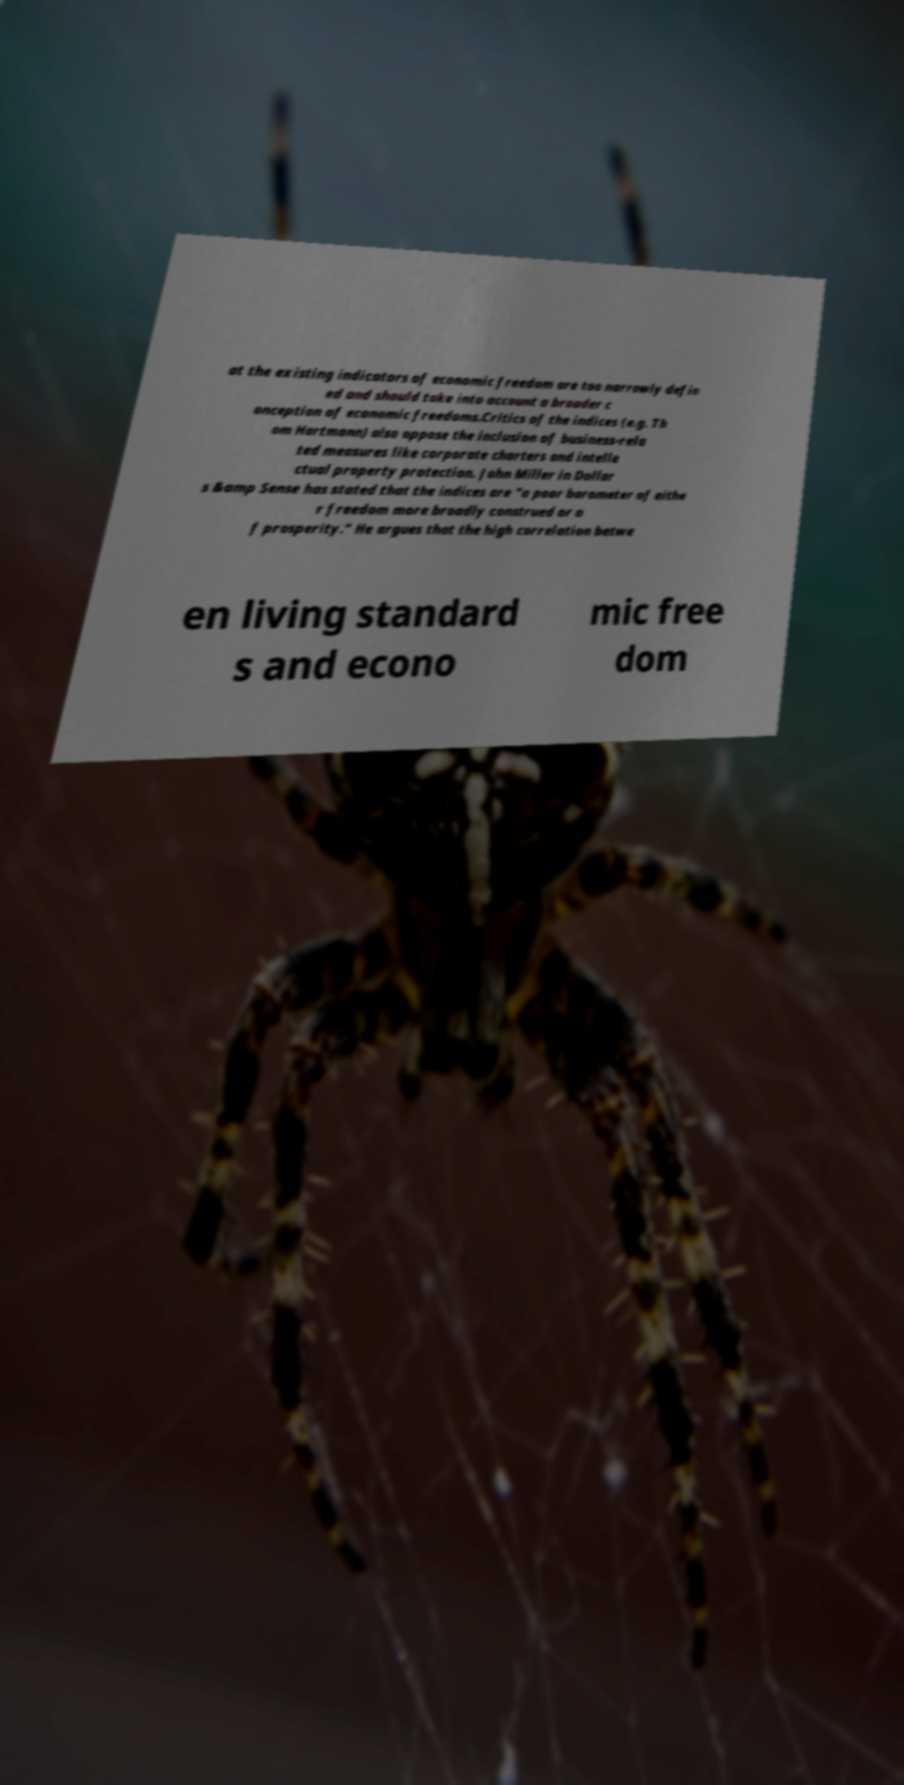Can you read and provide the text displayed in the image?This photo seems to have some interesting text. Can you extract and type it out for me? at the existing indicators of economic freedom are too narrowly defin ed and should take into account a broader c onception of economic freedoms.Critics of the indices (e.g. Th om Hartmann) also oppose the inclusion of business-rela ted measures like corporate charters and intelle ctual property protection. John Miller in Dollar s &amp Sense has stated that the indices are "a poor barometer of eithe r freedom more broadly construed or o f prosperity." He argues that the high correlation betwe en living standard s and econo mic free dom 